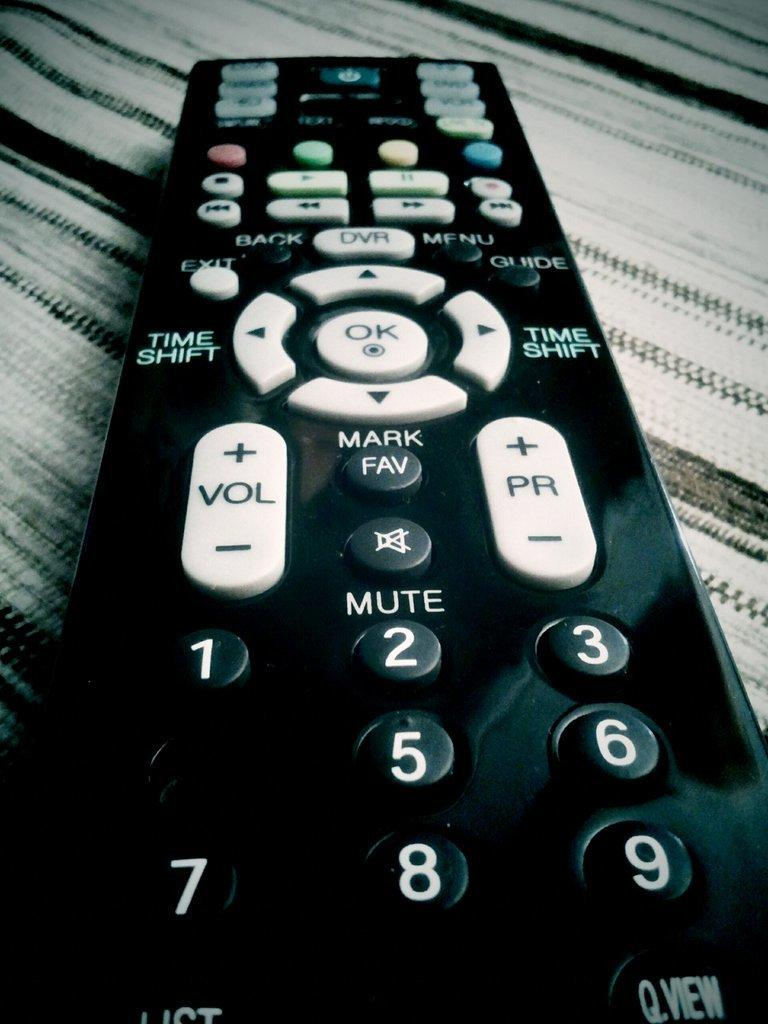<image>
Share a concise interpretation of the image provided. A close up of a remote with time shift and mute button among other ones. 